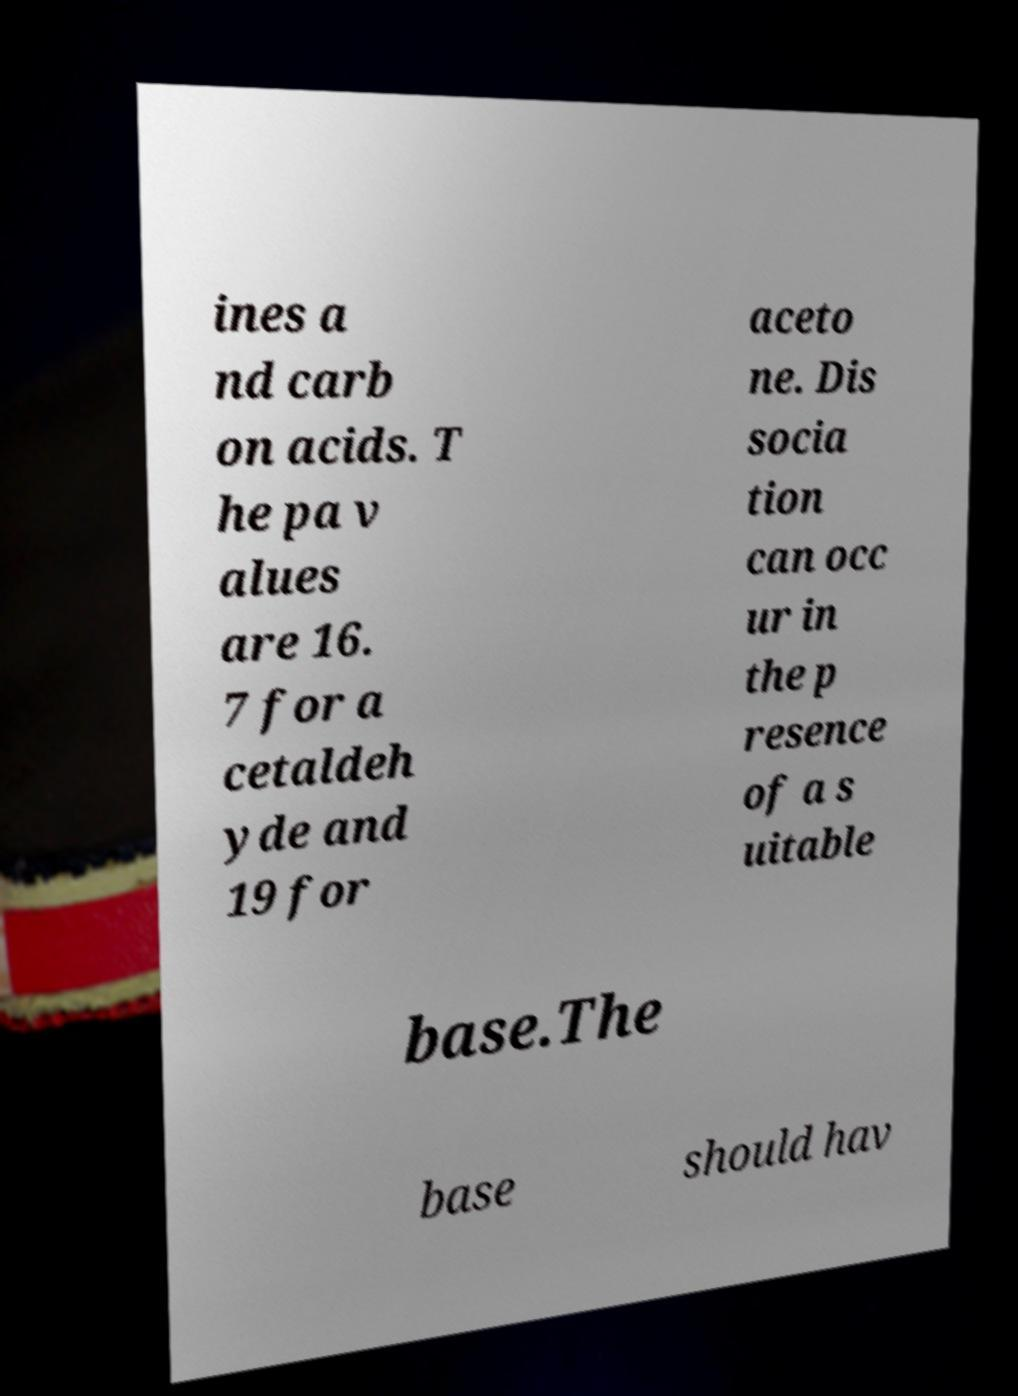Can you accurately transcribe the text from the provided image for me? ines a nd carb on acids. T he pa v alues are 16. 7 for a cetaldeh yde and 19 for aceto ne. Dis socia tion can occ ur in the p resence of a s uitable base.The base should hav 